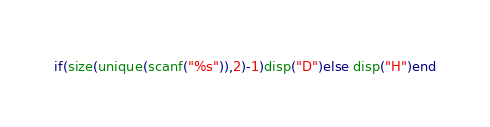<code> <loc_0><loc_0><loc_500><loc_500><_Octave_>if(size(unique(scanf("%s")),2)-1)disp("D")else disp("H")end</code> 